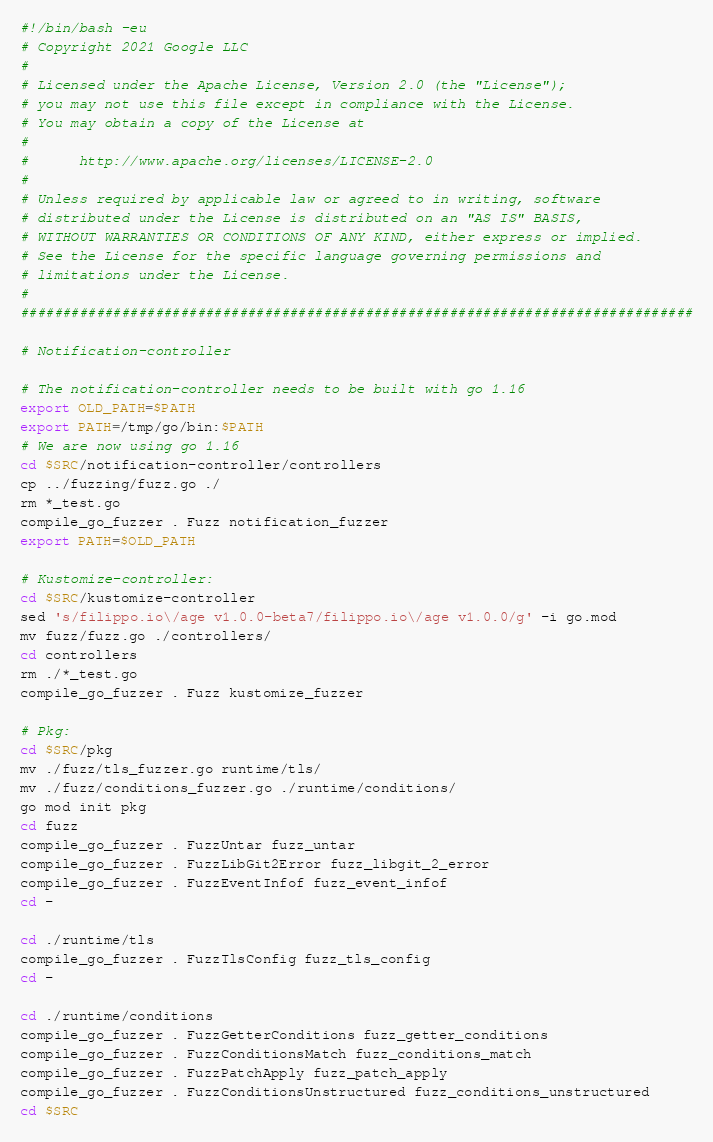Convert code to text. <code><loc_0><loc_0><loc_500><loc_500><_Bash_>#!/bin/bash -eu
# Copyright 2021 Google LLC
#
# Licensed under the Apache License, Version 2.0 (the "License");
# you may not use this file except in compliance with the License.
# You may obtain a copy of the License at
#
#      http://www.apache.org/licenses/LICENSE-2.0
#
# Unless required by applicable law or agreed to in writing, software
# distributed under the License is distributed on an "AS IS" BASIS,
# WITHOUT WARRANTIES OR CONDITIONS OF ANY KIND, either express or implied.
# See the License for the specific language governing permissions and
# limitations under the License.
#
################################################################################

# Notification-controller

# The notification-controller needs to be built with go 1.16
export OLD_PATH=$PATH
export PATH=/tmp/go/bin:$PATH
# We are now using go 1.16
cd $SRC/notification-controller/controllers
cp ../fuzzing/fuzz.go ./
rm *_test.go
compile_go_fuzzer . Fuzz notification_fuzzer
export PATH=$OLD_PATH

# Kustomize-controller:
cd $SRC/kustomize-controller
sed 's/filippo.io\/age v1.0.0-beta7/filippo.io\/age v1.0.0/g' -i go.mod
mv fuzz/fuzz.go ./controllers/
cd controllers
rm ./*_test.go
compile_go_fuzzer . Fuzz kustomize_fuzzer

# Pkg:
cd $SRC/pkg
mv ./fuzz/tls_fuzzer.go runtime/tls/
mv ./fuzz/conditions_fuzzer.go ./runtime/conditions/
go mod init pkg
cd fuzz
compile_go_fuzzer . FuzzUntar fuzz_untar
compile_go_fuzzer . FuzzLibGit2Error fuzz_libgit_2_error
compile_go_fuzzer . FuzzEventInfof fuzz_event_infof
cd -

cd ./runtime/tls
compile_go_fuzzer . FuzzTlsConfig fuzz_tls_config
cd -

cd ./runtime/conditions
compile_go_fuzzer . FuzzGetterConditions fuzz_getter_conditions
compile_go_fuzzer . FuzzConditionsMatch fuzz_conditions_match
compile_go_fuzzer . FuzzPatchApply fuzz_patch_apply
compile_go_fuzzer . FuzzConditionsUnstructured fuzz_conditions_unstructured
cd $SRC
</code> 